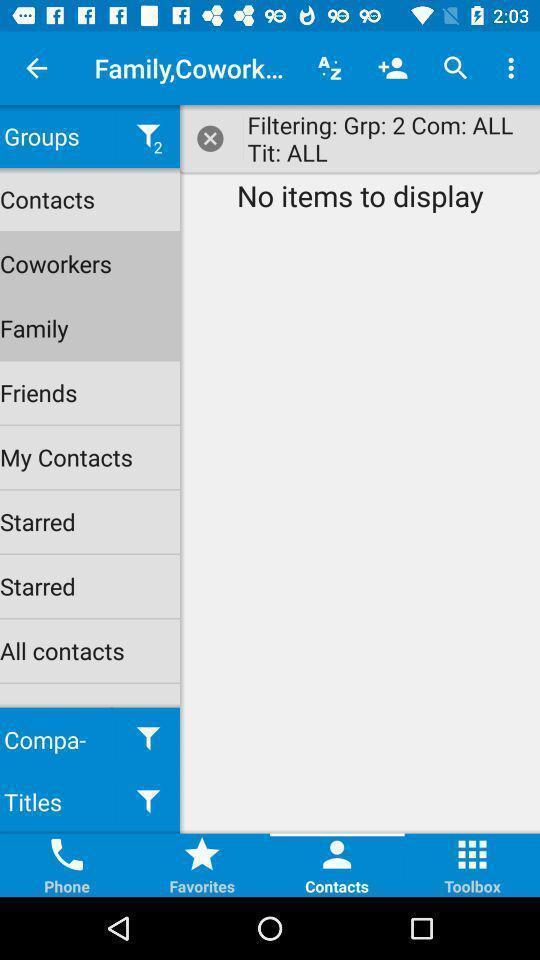Provide a textual representation of this image. Screen shows no items to display. 